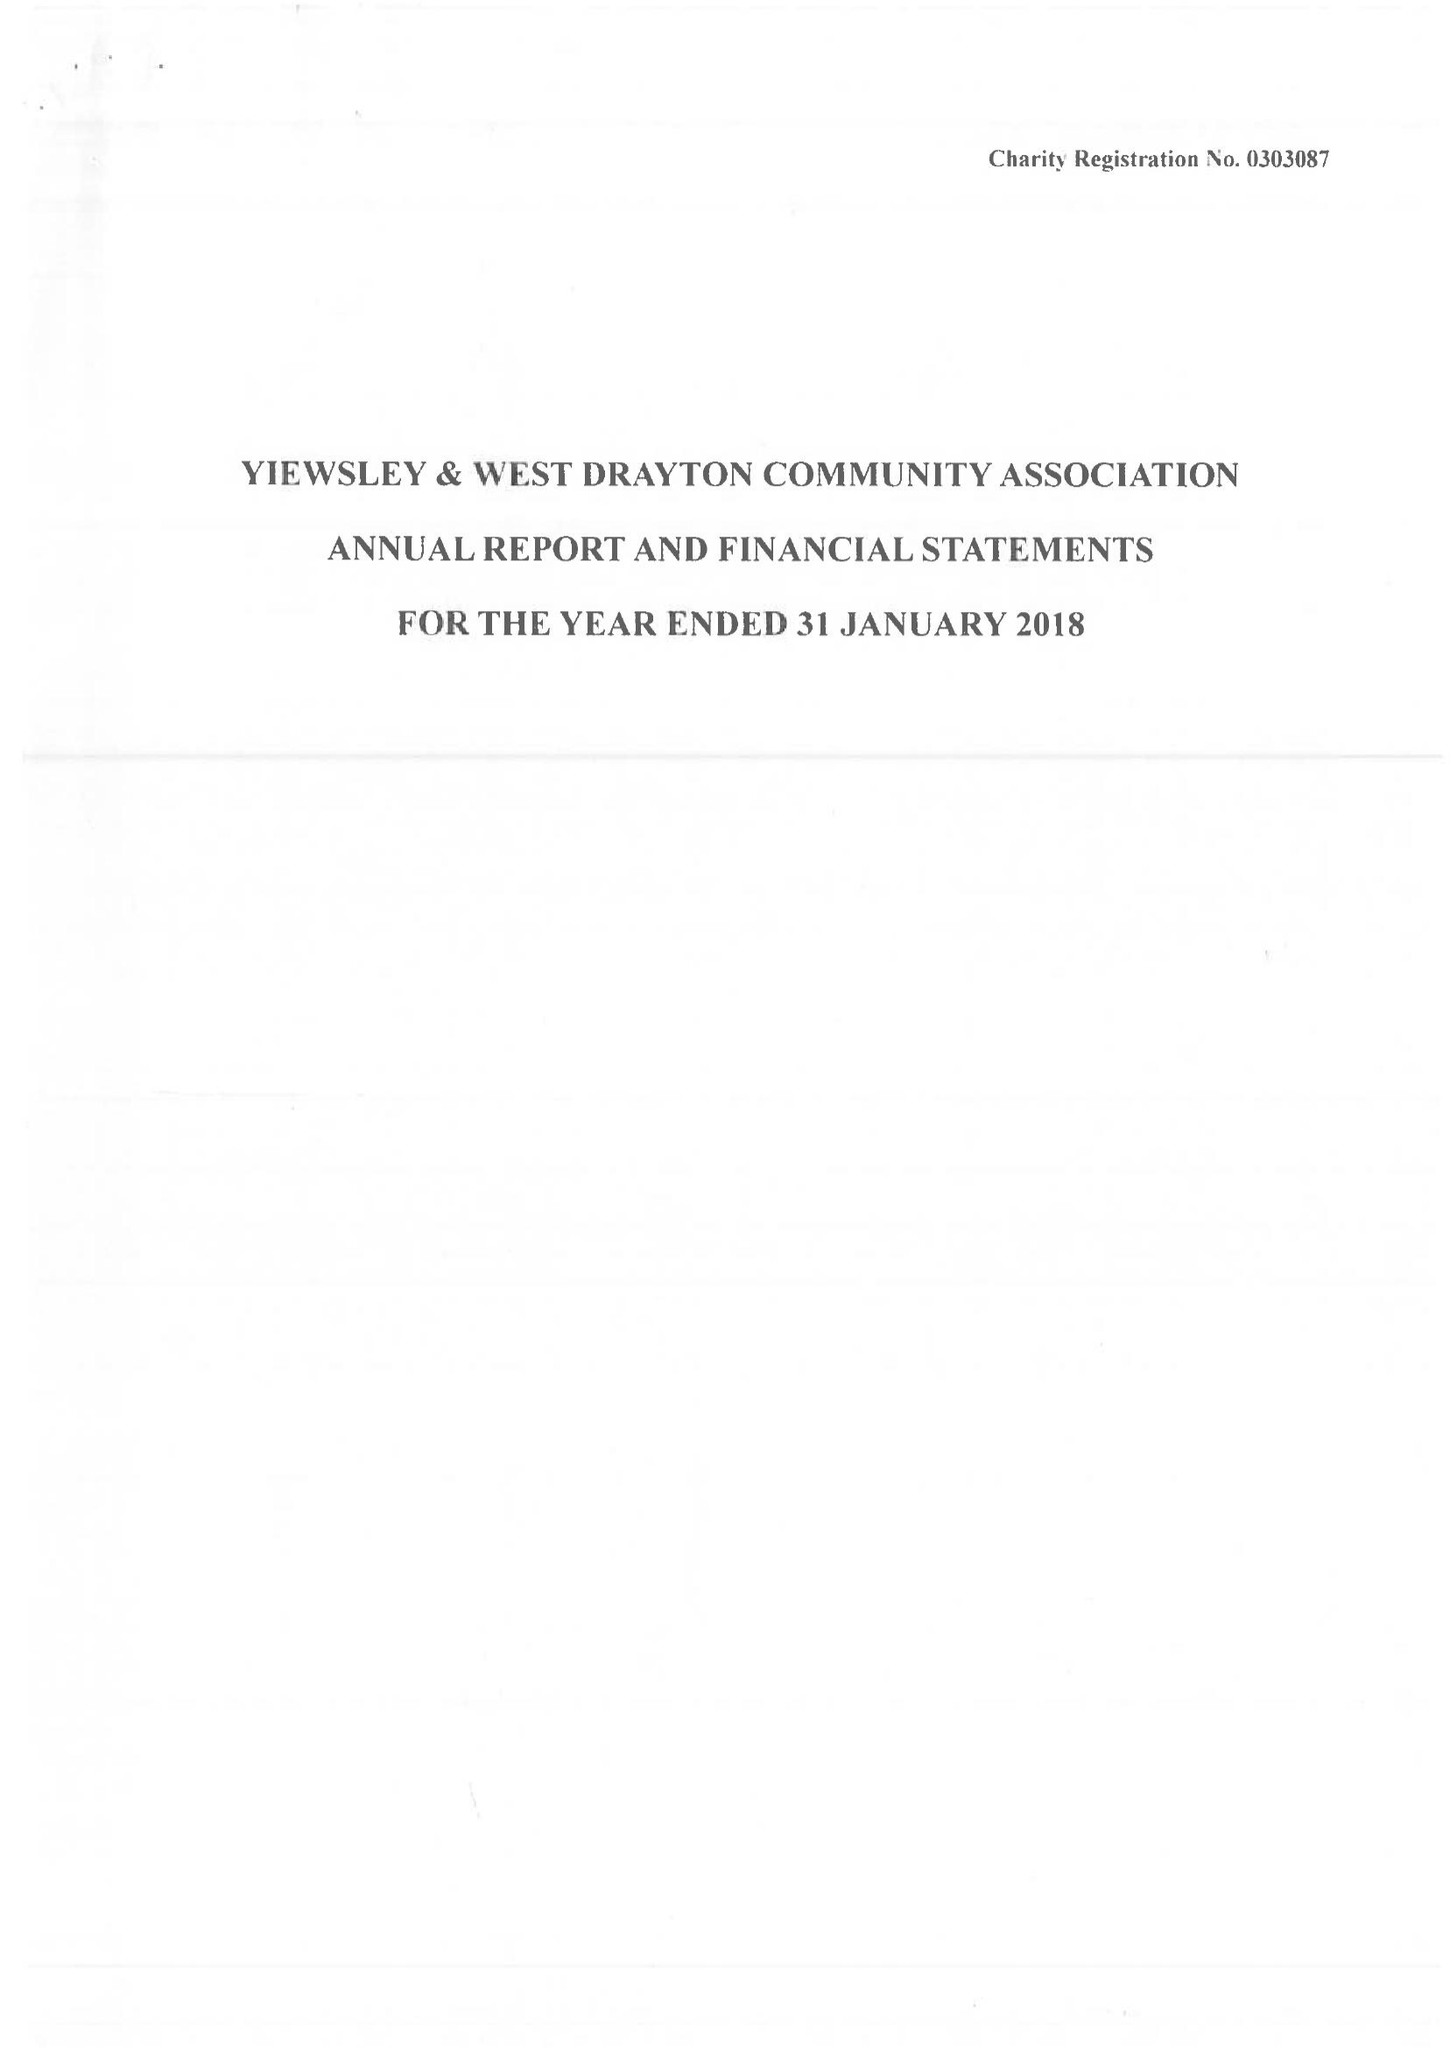What is the value for the report_date?
Answer the question using a single word or phrase. 2018-01-31 